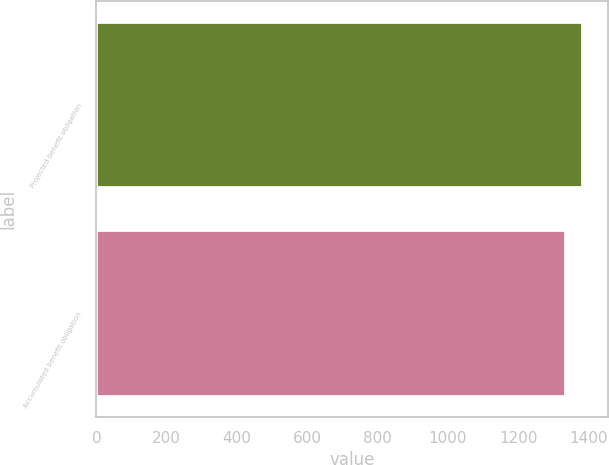Convert chart. <chart><loc_0><loc_0><loc_500><loc_500><bar_chart><fcel>Projected benefit obligation<fcel>Accumulated benefit obligation<nl><fcel>1385<fcel>1334.7<nl></chart> 